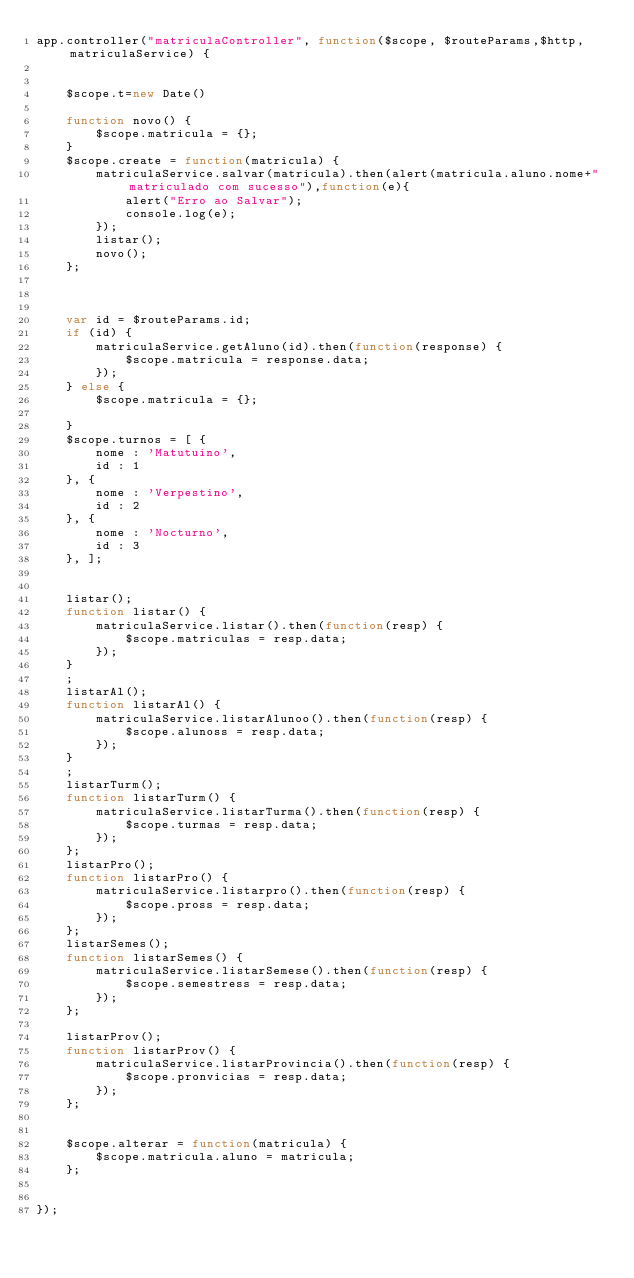<code> <loc_0><loc_0><loc_500><loc_500><_JavaScript_>app.controller("matriculaController", function($scope, $routeParams,$http, matriculaService) {


	$scope.t=new Date()
	
	function novo() {
		$scope.matricula = {};
	}
	$scope.create = function(matricula) {
		matriculaService.salvar(matricula).then(alert(matricula.aluno.nome+" matriculado com sucesso"),function(e){
			alert("Erro ao Salvar");
			console.log(e);
		});
		listar();
		novo();
	};
	
	

	var id = $routeParams.id;
	if (id) {
		matriculaService.getAluno(id).then(function(response) {
			$scope.matricula = response.data;
		});
	} else {
		$scope.matricula = {};

	}
	$scope.turnos = [ {
		nome : 'Matutuino',
		id : 1
	}, {
		nome : 'Verpestino',
		id : 2
	}, {
		nome : 'Nocturno',
		id : 3
	}, ];
	

	listar();
	function listar() {
		matriculaService.listar().then(function(resp) {
			$scope.matriculas = resp.data;
		});
	}
	;
	listarAl();
	function listarAl() {
		matriculaService.listarAlunoo().then(function(resp) {
			$scope.alunoss = resp.data;
		});
	}
	;
	listarTurm();
	function listarTurm() {
		matriculaService.listarTurma().then(function(resp) {
			$scope.turmas = resp.data;
		});
	};
	listarPro();
	function listarPro() {
		matriculaService.listarpro().then(function(resp) {
			$scope.pross = resp.data;
		});
	};
	listarSemes();
	function listarSemes() {
		matriculaService.listarSemese().then(function(resp) {
			$scope.semestress = resp.data;
		});
	};
	
	listarProv();
	function listarProv() {
		matriculaService.listarProvincia().then(function(resp) {
			$scope.pronvicias = resp.data;
		});
	};
	

	$scope.alterar = function(matricula) {
		$scope.matricula.aluno = matricula;
	};

	
});
</code> 